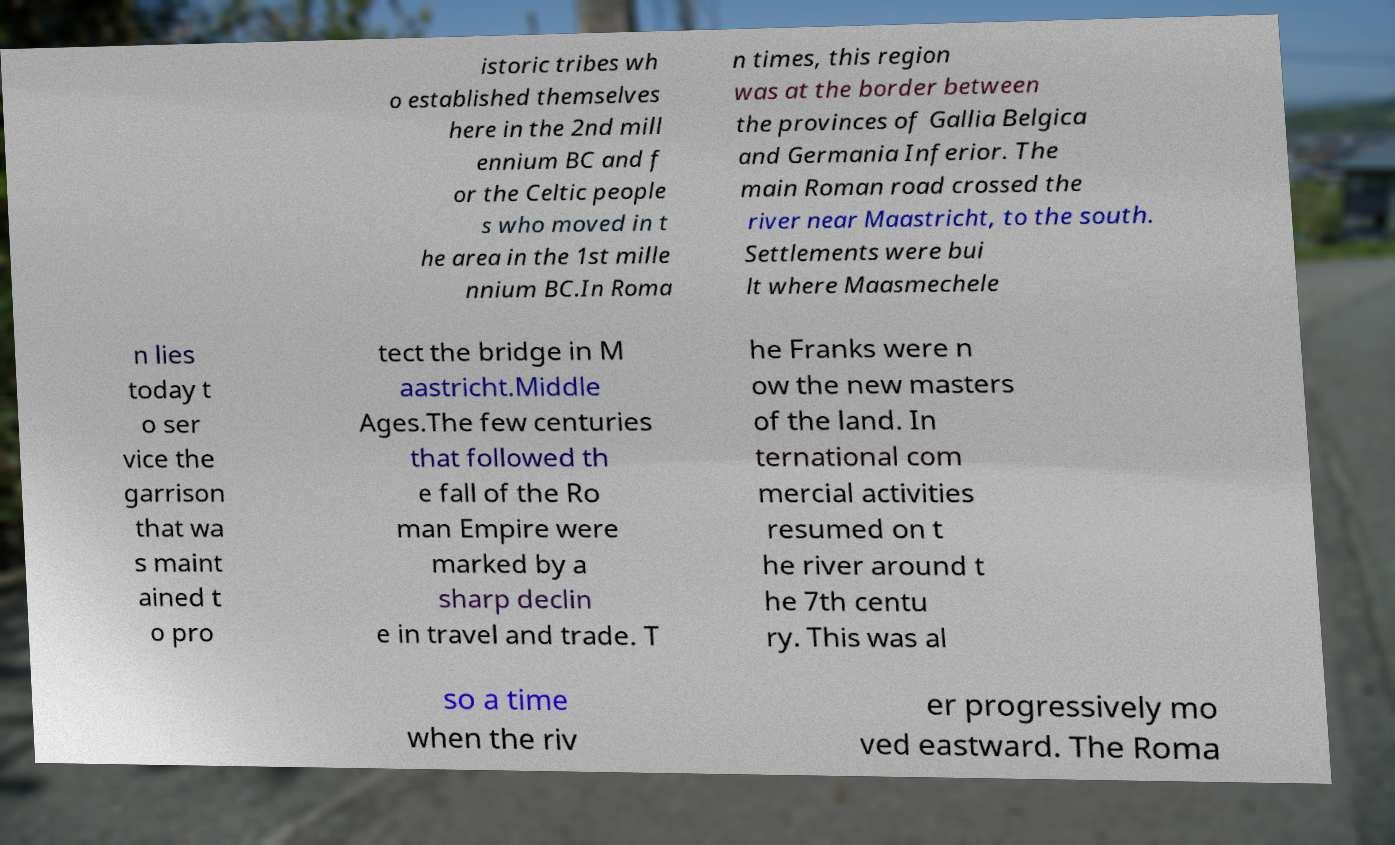Please read and relay the text visible in this image. What does it say? istoric tribes wh o established themselves here in the 2nd mill ennium BC and f or the Celtic people s who moved in t he area in the 1st mille nnium BC.In Roma n times, this region was at the border between the provinces of Gallia Belgica and Germania Inferior. The main Roman road crossed the river near Maastricht, to the south. Settlements were bui lt where Maasmechele n lies today t o ser vice the garrison that wa s maint ained t o pro tect the bridge in M aastricht.Middle Ages.The few centuries that followed th e fall of the Ro man Empire were marked by a sharp declin e in travel and trade. T he Franks were n ow the new masters of the land. In ternational com mercial activities resumed on t he river around t he 7th centu ry. This was al so a time when the riv er progressively mo ved eastward. The Roma 